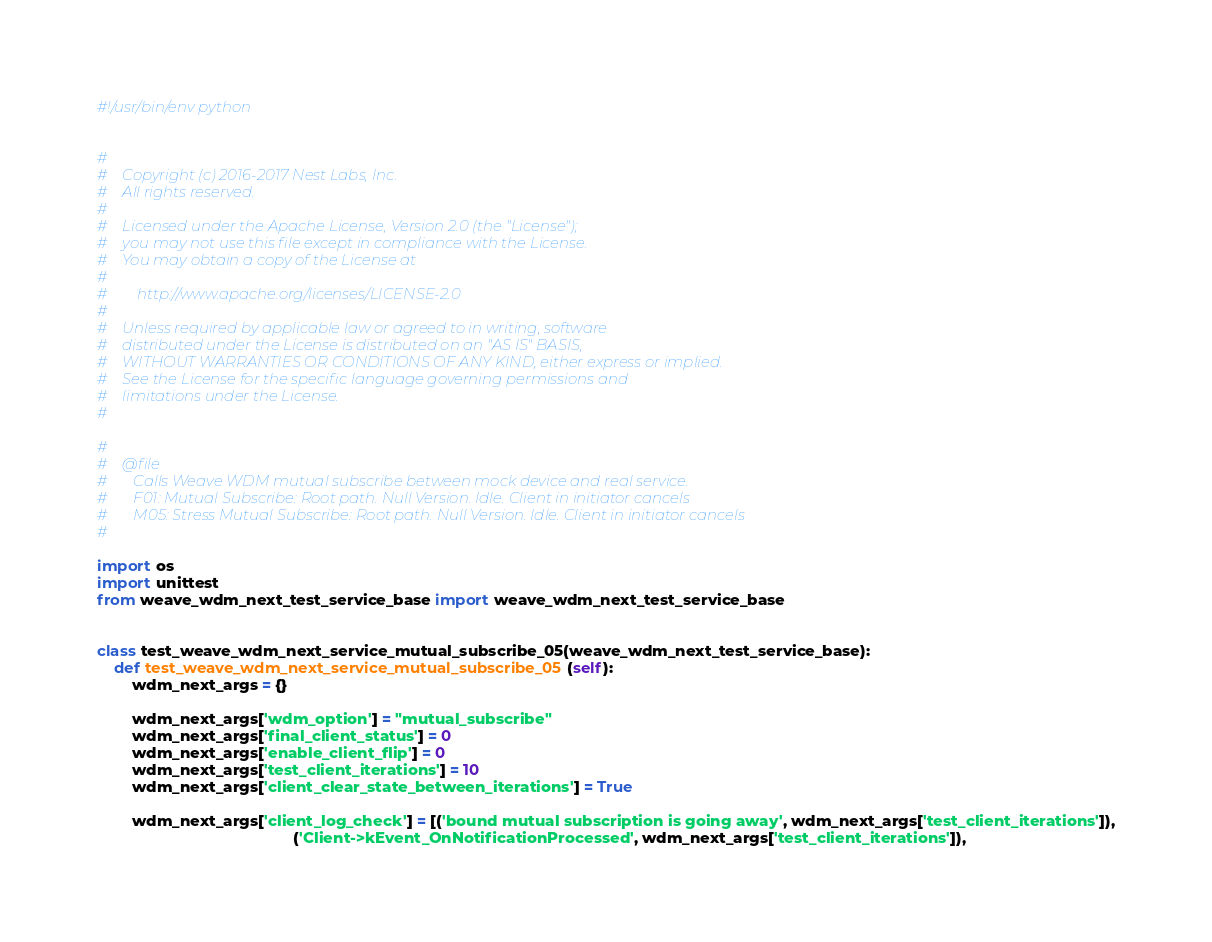<code> <loc_0><loc_0><loc_500><loc_500><_Python_>#!/usr/bin/env python


#
#    Copyright (c) 2016-2017 Nest Labs, Inc.
#    All rights reserved.
#
#    Licensed under the Apache License, Version 2.0 (the "License");
#    you may not use this file except in compliance with the License.
#    You may obtain a copy of the License at
#
#        http://www.apache.org/licenses/LICENSE-2.0
#
#    Unless required by applicable law or agreed to in writing, software
#    distributed under the License is distributed on an "AS IS" BASIS,
#    WITHOUT WARRANTIES OR CONDITIONS OF ANY KIND, either express or implied.
#    See the License for the specific language governing permissions and
#    limitations under the License.
#

#
#    @file
#       Calls Weave WDM mutual subscribe between mock device and real service.
#       F01: Mutual Subscribe: Root path. Null Version. Idle. Client in initiator cancels
#       M05: Stress Mutual Subscribe: Root path. Null Version. Idle. Client in initiator cancels
#

import os
import unittest
from weave_wdm_next_test_service_base import weave_wdm_next_test_service_base


class test_weave_wdm_next_service_mutual_subscribe_05(weave_wdm_next_test_service_base):
    def test_weave_wdm_next_service_mutual_subscribe_05(self):
        wdm_next_args = {}

        wdm_next_args['wdm_option'] = "mutual_subscribe"
        wdm_next_args['final_client_status'] = 0
        wdm_next_args['enable_client_flip'] = 0
        wdm_next_args['test_client_iterations'] = 10
        wdm_next_args['client_clear_state_between_iterations'] = True

        wdm_next_args['client_log_check'] = [('bound mutual subscription is going away', wdm_next_args['test_client_iterations']),
                                             ('Client->kEvent_OnNotificationProcessed', wdm_next_args['test_client_iterations']),</code> 